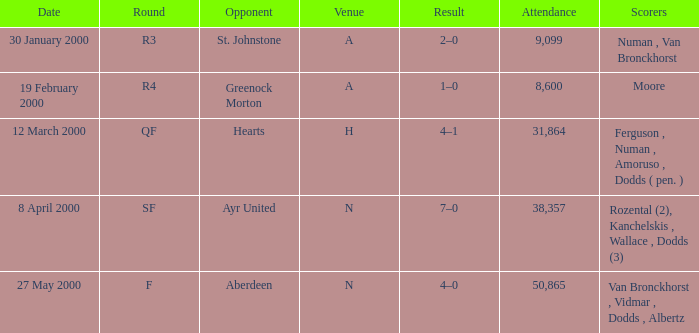Who participated alongside st. johnstone in a match? Numan , Van Bronckhorst. Give me the full table as a dictionary. {'header': ['Date', 'Round', 'Opponent', 'Venue', 'Result', 'Attendance', 'Scorers'], 'rows': [['30 January 2000', 'R3', 'St. Johnstone', 'A', '2–0', '9,099', 'Numan , Van Bronckhorst'], ['19 February 2000', 'R4', 'Greenock Morton', 'A', '1–0', '8,600', 'Moore'], ['12 March 2000', 'QF', 'Hearts', 'H', '4–1', '31,864', 'Ferguson , Numan , Amoruso , Dodds ( pen. )'], ['8 April 2000', 'SF', 'Ayr United', 'N', '7–0', '38,357', 'Rozental (2), Kanchelskis , Wallace , Dodds (3)'], ['27 May 2000', 'F', 'Aberdeen', 'N', '4–0', '50,865', 'Van Bronckhorst , Vidmar , Dodds , Albertz']]} 